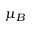<formula> <loc_0><loc_0><loc_500><loc_500>\mu _ { B }</formula> 